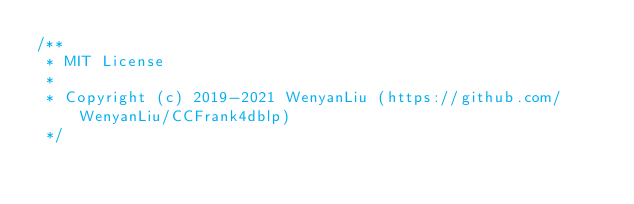Convert code to text. <code><loc_0><loc_0><loc_500><loc_500><_JavaScript_>/**
 * MIT License
 *
 * Copyright (c) 2019-2021 WenyanLiu (https://github.com/WenyanLiu/CCFrank4dblp)
 */
</code> 